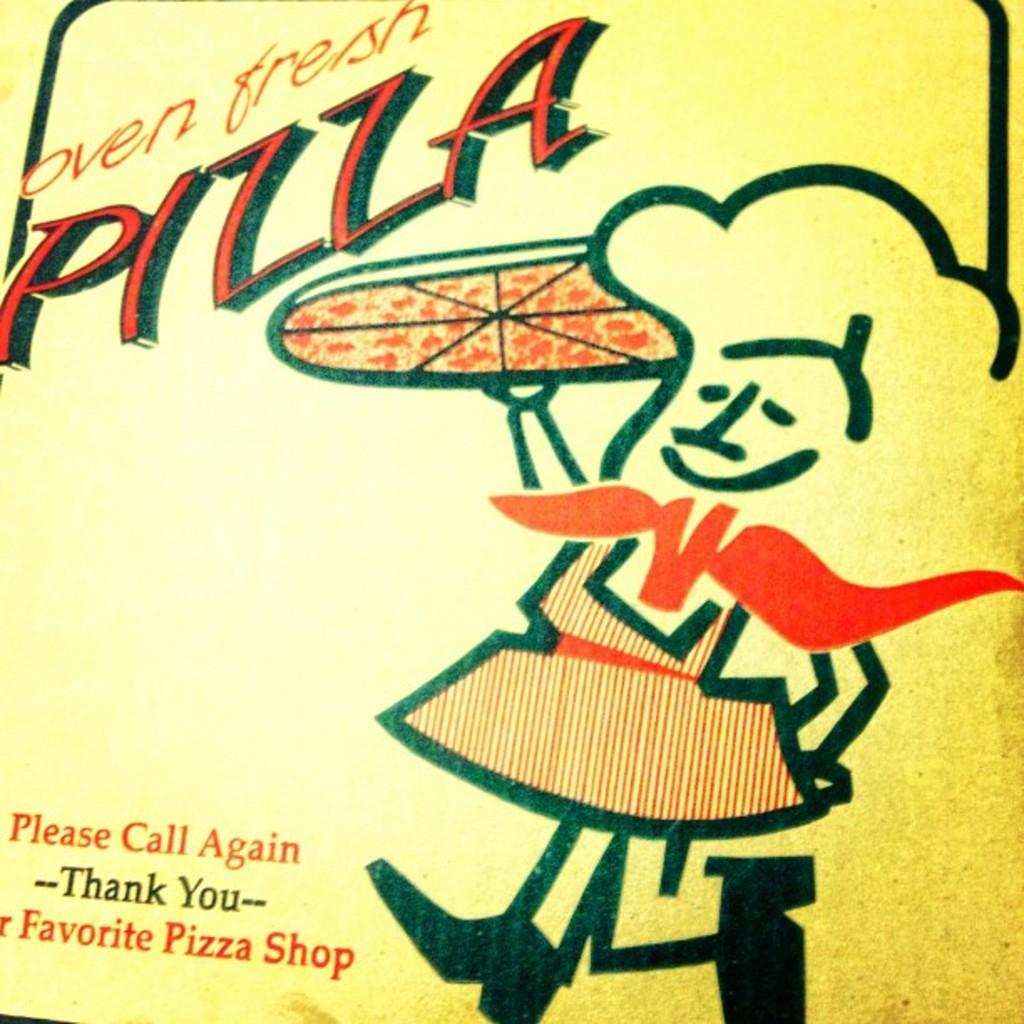<image>
Provide a brief description of the given image. A cartoon drawing of a pizza chef for a pizza shop that has oven fresh pizza. 